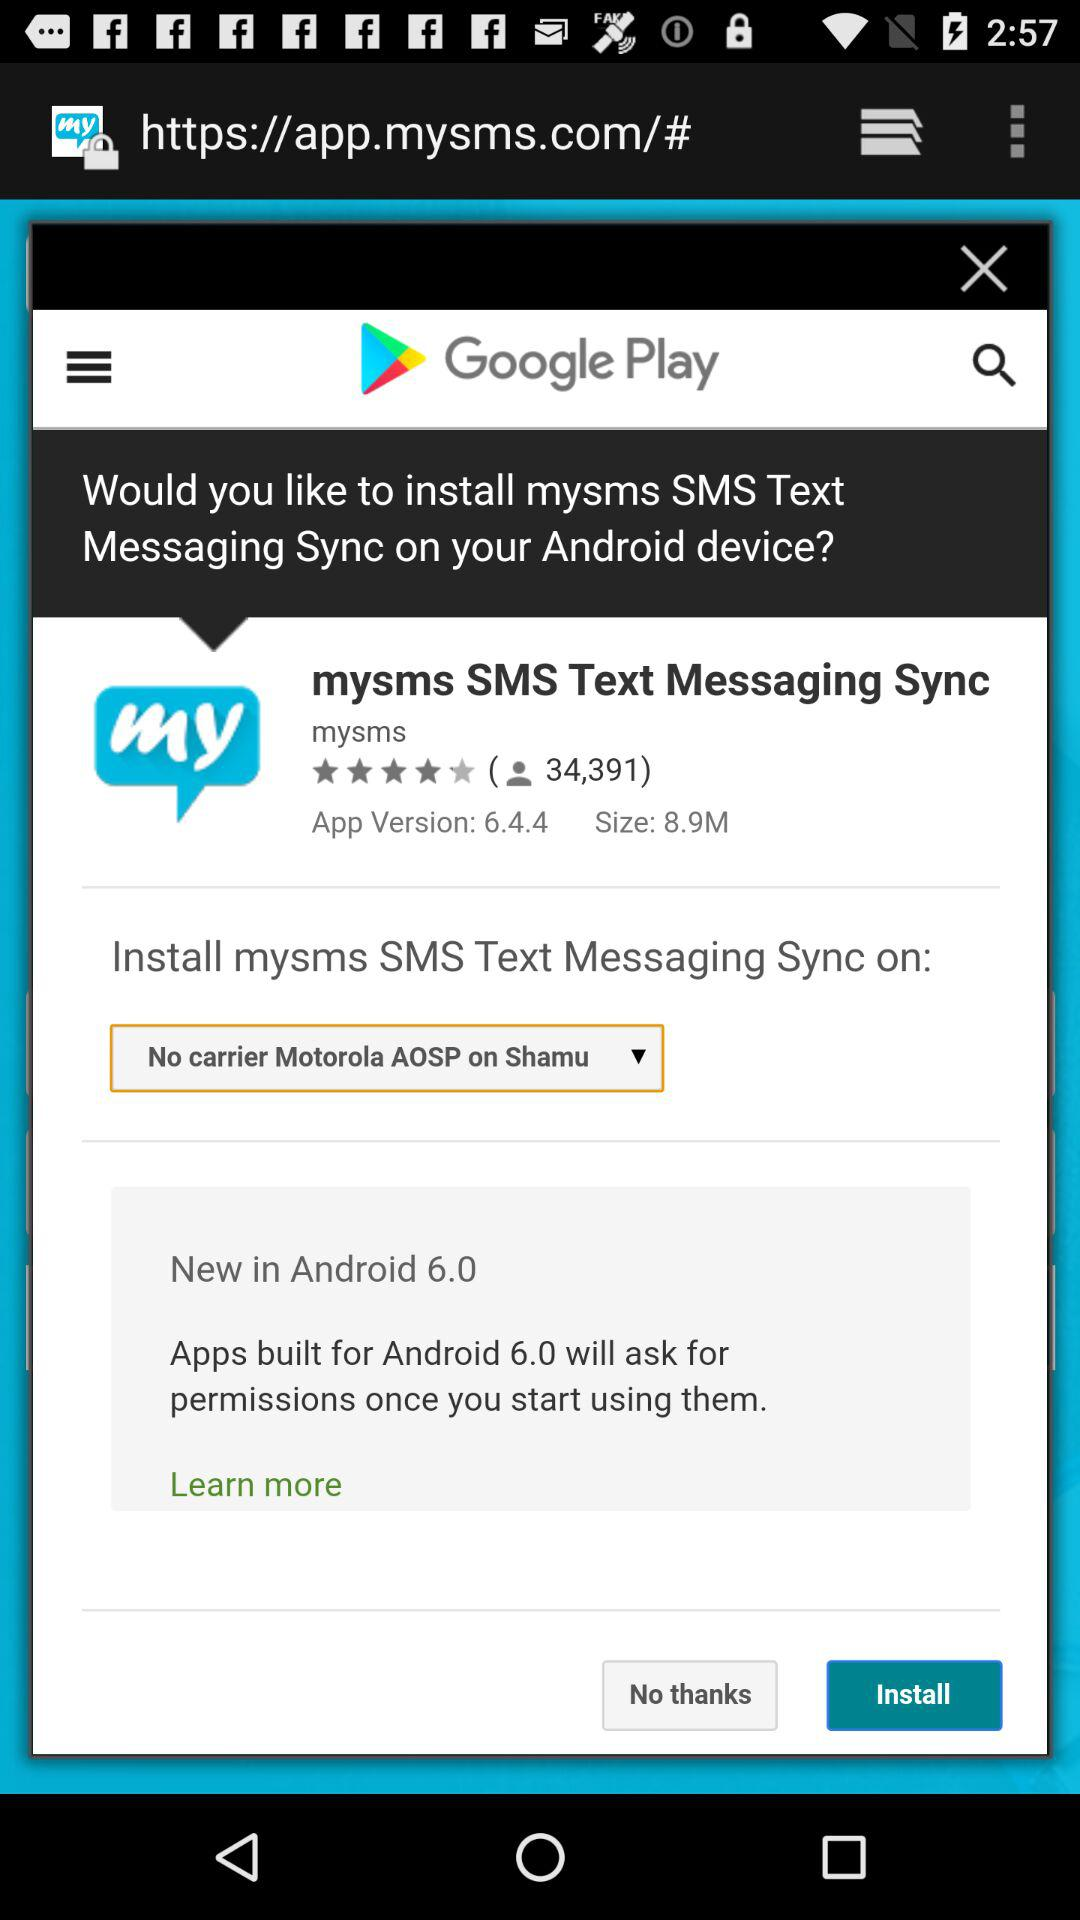What's the size of the app? The size of the app is 8.9M. 